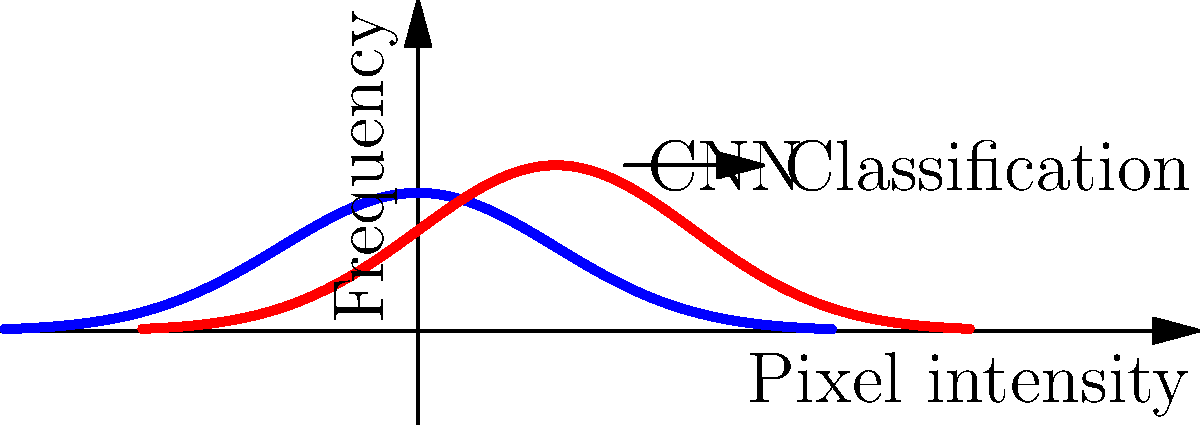In a convolutional neural network (CNN) designed to identify cancerous cells in medical imaging scans, how does the distribution of pixel intensities typically differ between normal and cancerous tissues, and how does this impact the CNN's ability to distinguish between them? 1. Distribution of pixel intensities:
   - Normal tissue (blue curve): Typically follows a more symmetrical, unimodal distribution centered around a lower pixel intensity value.
   - Cancerous tissue (red curve): Often shows a shifted, sometimes broader or multimodal distribution, centered at a higher pixel intensity value.

2. Impact on CNN's ability to distinguish:
   a) Feature extraction: The CNN's convolutional layers extract features based on these intensity patterns.
   b) Learned filters: The network learns to recognize the distinctive patterns associated with each tissue type.
   c) Activation maps: Differences in pixel intensity distributions lead to different activation patterns in the CNN's layers.

3. Classification process:
   a) The CNN processes the input image through multiple convolutional and pooling layers.
   b) Features are extracted and combined in increasingly complex representations.
   c) Fully connected layers use these features to make a final classification decision.

4. Importance for cancer survivors:
   - Understanding this process helps appreciate the technology used in their diagnosis and ongoing monitoring.
   - It emphasizes the importance of regular check-ups and the power of advanced imaging techniques in early detection.

5. Challenges and considerations:
   - Overlap in distributions can lead to false positives or negatives.
   - CNN performance depends on the quality and diversity of training data.
   - Regular updates and refinements to the model are necessary to maintain accuracy.
Answer: Cancerous tissues typically show higher, shifted pixel intensity distributions, enabling CNNs to distinguish them from normal tissues through learned feature extraction and classification. 